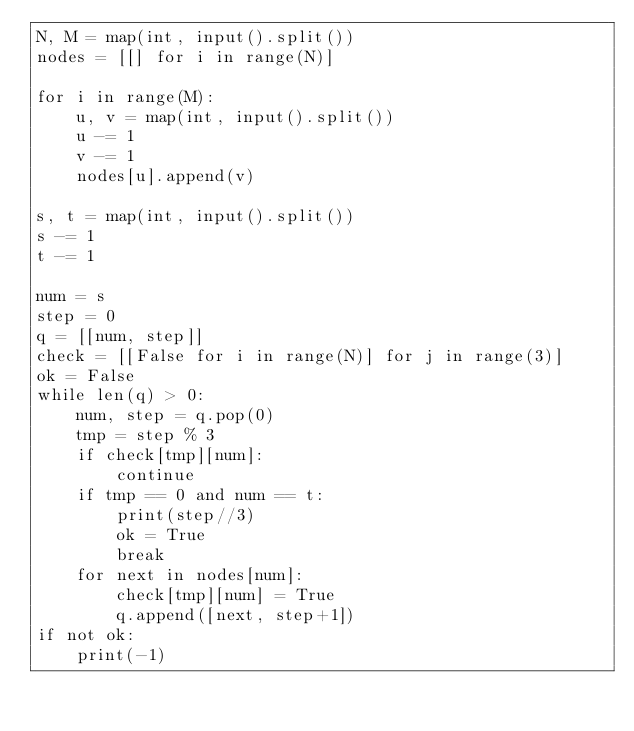<code> <loc_0><loc_0><loc_500><loc_500><_Python_>N, M = map(int, input().split())
nodes = [[] for i in range(N)]

for i in range(M):
    u, v = map(int, input().split())
    u -= 1
    v -= 1
    nodes[u].append(v)

s, t = map(int, input().split())
s -= 1
t -= 1

num = s
step = 0
q = [[num, step]]
check = [[False for i in range(N)] for j in range(3)]
ok = False
while len(q) > 0:
    num, step = q.pop(0)
    tmp = step % 3
    if check[tmp][num]:
        continue
    if tmp == 0 and num == t:
        print(step//3)
        ok = True
        break
    for next in nodes[num]:
        check[tmp][num] = True
        q.append([next, step+1])
if not ok:
    print(-1)
</code> 